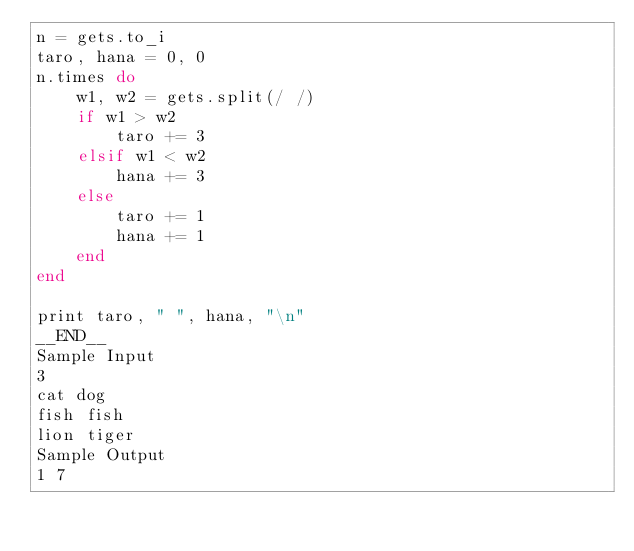<code> <loc_0><loc_0><loc_500><loc_500><_Ruby_>n = gets.to_i
taro, hana = 0, 0
n.times do
    w1, w2 = gets.split(/ /)
    if w1 > w2
        taro += 3
    elsif w1 < w2
        hana += 3
    else
        taro += 1
        hana += 1
    end
end

print taro, " ", hana, "\n"
__END__
Sample Input
3
cat dog
fish fish
lion tiger
Sample Output
1 7</code> 